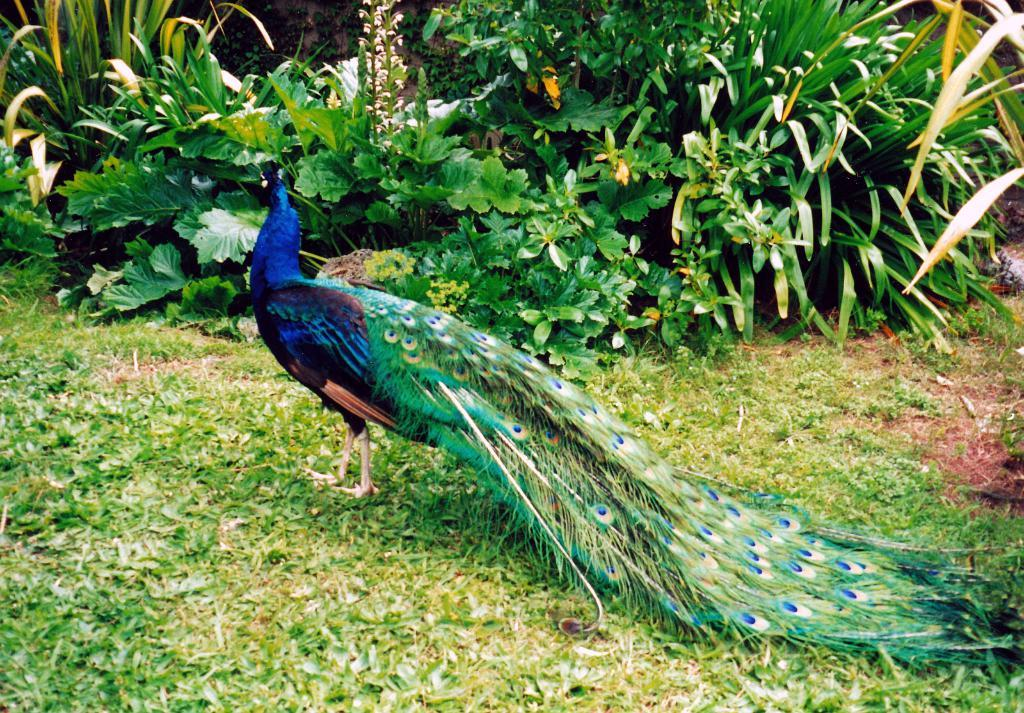What animal is located in the middle of the image? There is a peacock in the middle of the image. What type of vegetation can be seen at the top of the image? There are plants at the top of the image. What type of powder is being used by the fireman in the image? There is no fireman or powder present in the image; it features a peacock and plants. 